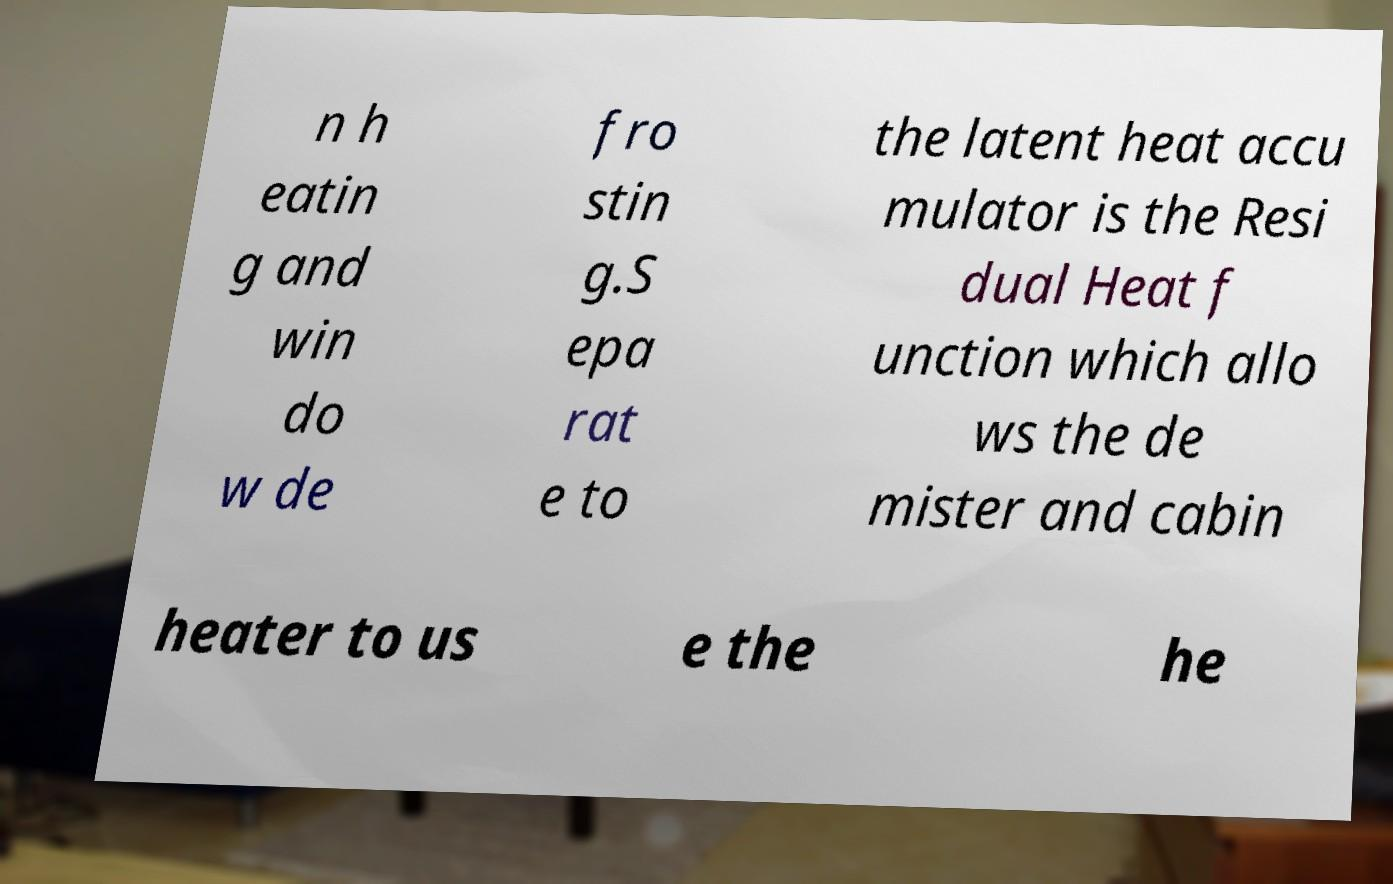I need the written content from this picture converted into text. Can you do that? n h eatin g and win do w de fro stin g.S epa rat e to the latent heat accu mulator is the Resi dual Heat f unction which allo ws the de mister and cabin heater to us e the he 